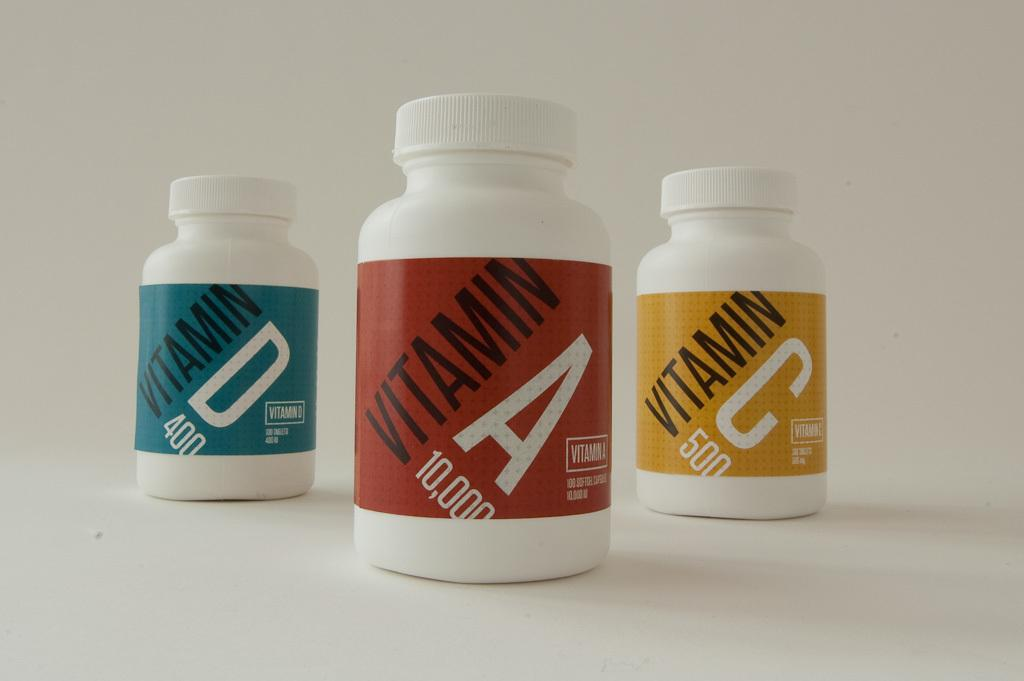<image>
Create a compact narrative representing the image presented. Three pill bottleswith vitamins A, C and D in them. 